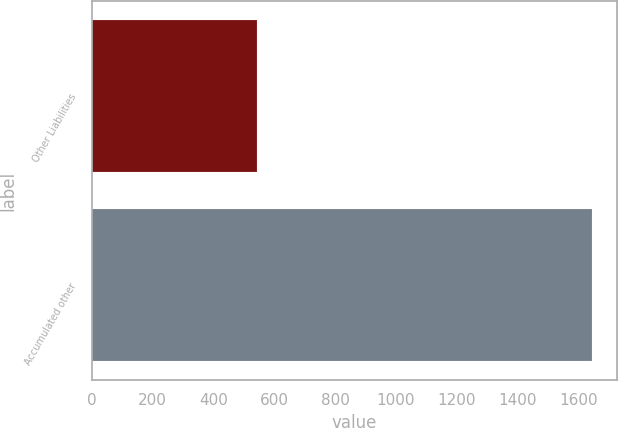<chart> <loc_0><loc_0><loc_500><loc_500><bar_chart><fcel>Other Liabilities<fcel>Accumulated other<nl><fcel>544<fcel>1645<nl></chart> 